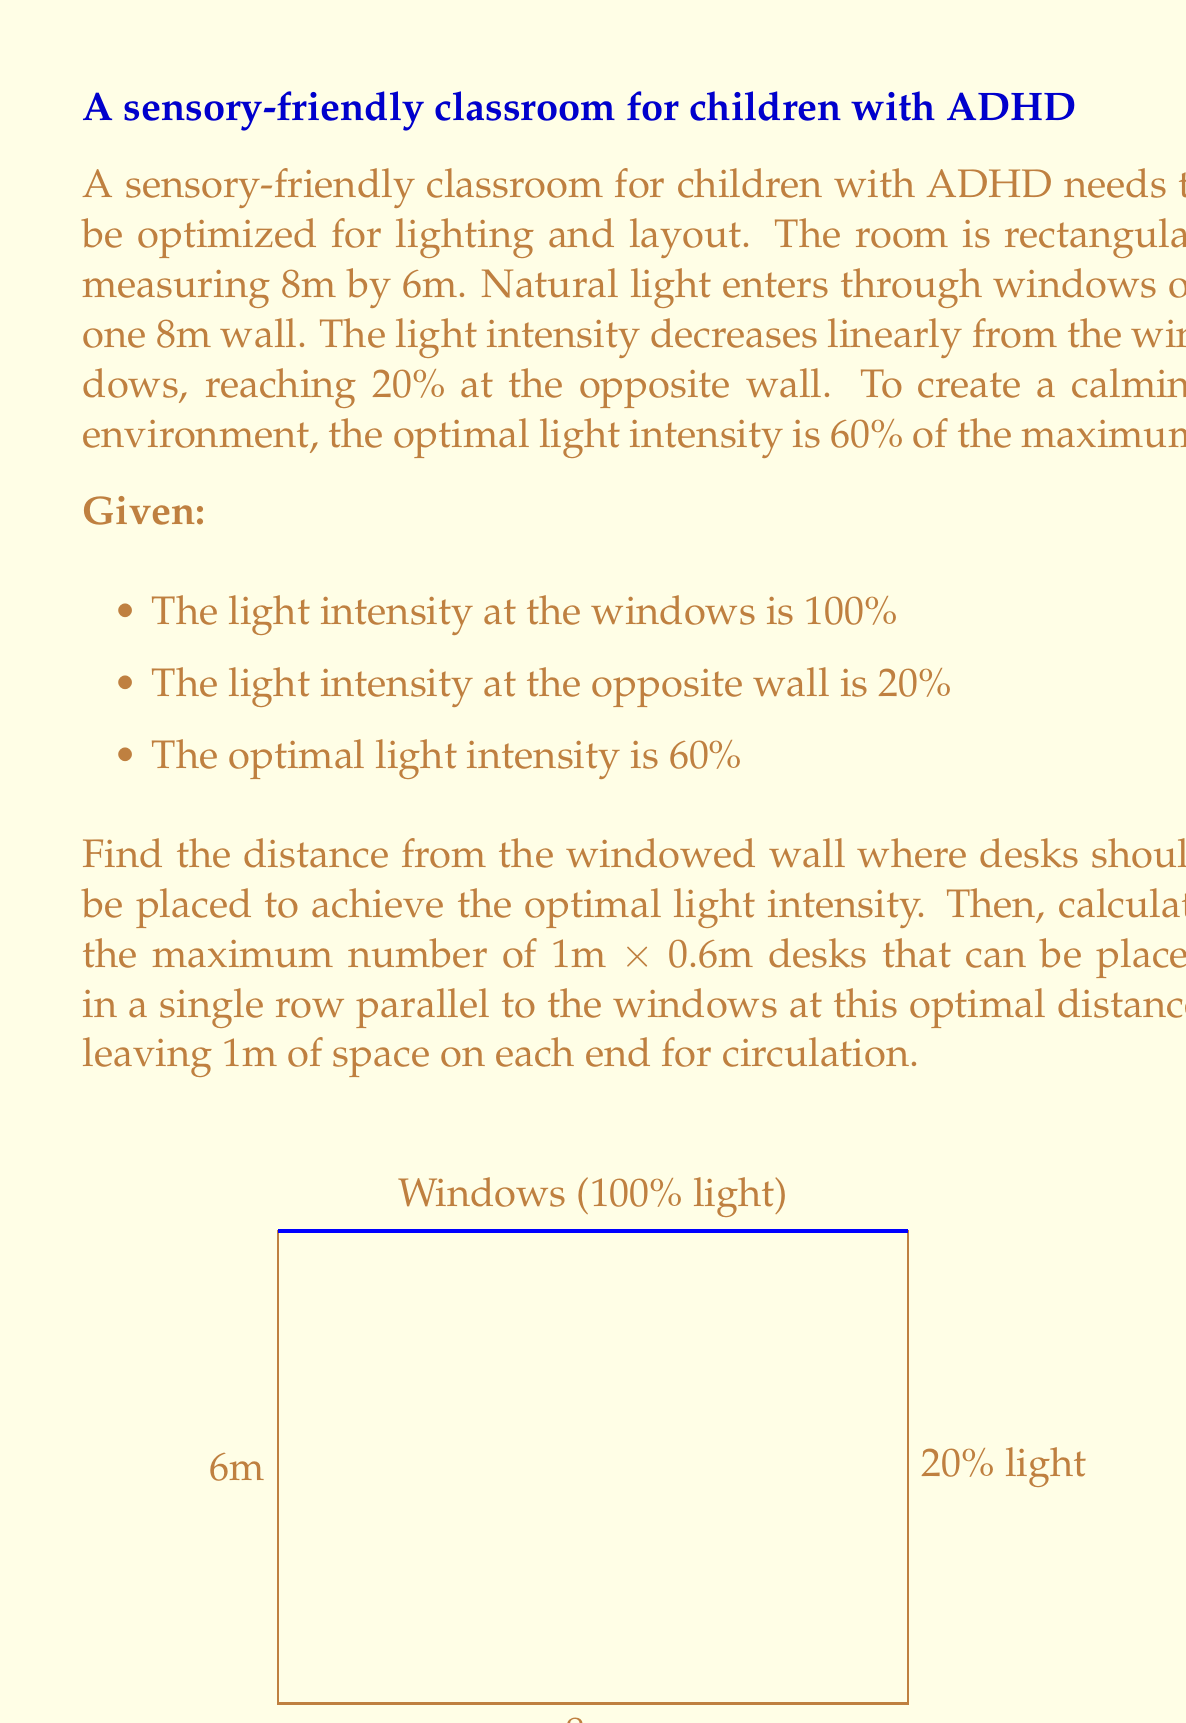Show me your answer to this math problem. Let's approach this step-by-step:

1) First, we need to find the equation for light intensity as a function of distance from the windowed wall.

   Let $x$ be the distance from the windowed wall in meters.
   Let $y$ be the light intensity as a percentage.

   We know two points: (0, 100) and (6, 20)

   Using the point-slope form of a line:
   $y - y_1 = m(x - x_1)$
   $y - 100 = m(x - 0)$

   The slope $m$ can be calculated:
   $m = \frac{20 - 100}{6 - 0} = -\frac{80}{6} = -\frac{40}{3}$

   So our equation is:
   $y - 100 = -\frac{40}{3}x$
   $y = -\frac{40}{3}x + 100$

2) Now, we want to find $x$ when $y = 60$ (the optimal light intensity):

   $60 = -\frac{40}{3}x + 100$
   $-40 = -\frac{40}{3}x$
   $x = 3$

3) So the desks should be placed 3 meters from the windowed wall.

4) To calculate the number of desks:
   - The room is 8m wide
   - We need 1m on each end for circulation
   - This leaves 6m for desks

   Each desk is 0.6m wide, so:
   $\text{Number of desks} = \lfloor\frac{6}{0.6}\rfloor = \lfloor10\rfloor = 10$

   The floor function $\lfloor \rfloor$ is used to ensure we get a whole number of desks.
Answer: 3m from windows; 10 desks 